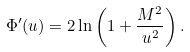<formula> <loc_0><loc_0><loc_500><loc_500>\Phi ^ { \prime } ( u ) = 2 \ln \left ( 1 + \frac { M ^ { 2 } } { u ^ { 2 } } \right ) .</formula> 